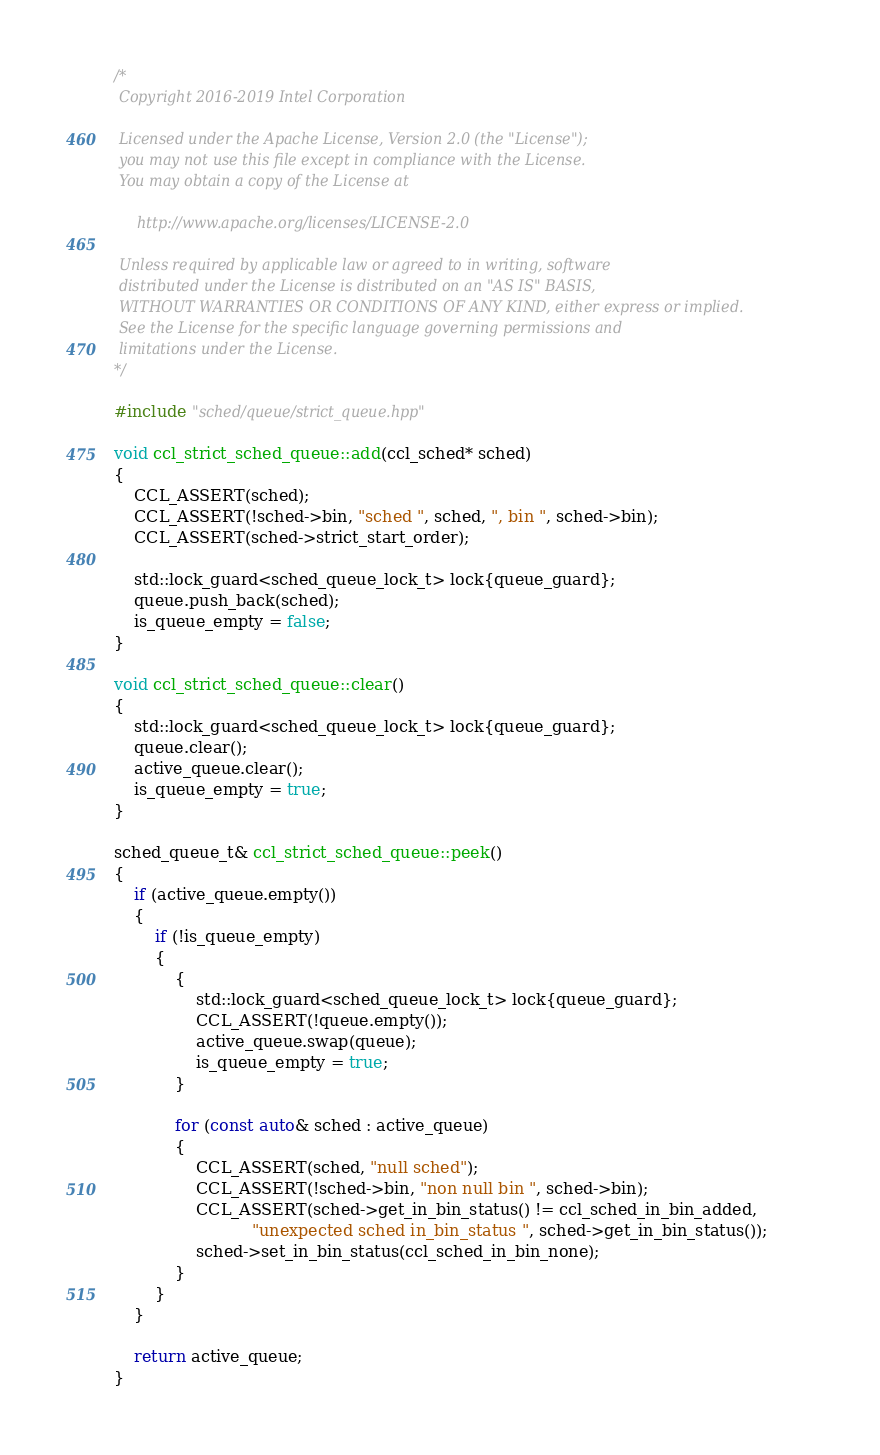<code> <loc_0><loc_0><loc_500><loc_500><_C++_>/*
 Copyright 2016-2019 Intel Corporation
 
 Licensed under the Apache License, Version 2.0 (the "License");
 you may not use this file except in compliance with the License.
 You may obtain a copy of the License at
 
     http://www.apache.org/licenses/LICENSE-2.0
 
 Unless required by applicable law or agreed to in writing, software
 distributed under the License is distributed on an "AS IS" BASIS,
 WITHOUT WARRANTIES OR CONDITIONS OF ANY KIND, either express or implied.
 See the License for the specific language governing permissions and
 limitations under the License.
*/

#include "sched/queue/strict_queue.hpp"

void ccl_strict_sched_queue::add(ccl_sched* sched)
{
    CCL_ASSERT(sched);
    CCL_ASSERT(!sched->bin, "sched ", sched, ", bin ", sched->bin);
    CCL_ASSERT(sched->strict_start_order);

    std::lock_guard<sched_queue_lock_t> lock{queue_guard};
    queue.push_back(sched);
    is_queue_empty = false;
}

void ccl_strict_sched_queue::clear()
{
    std::lock_guard<sched_queue_lock_t> lock{queue_guard};
    queue.clear();
    active_queue.clear();
    is_queue_empty = true;
}

sched_queue_t& ccl_strict_sched_queue::peek()
{
    if (active_queue.empty())
    {
        if (!is_queue_empty)
        {
            {
                std::lock_guard<sched_queue_lock_t> lock{queue_guard};
                CCL_ASSERT(!queue.empty());
                active_queue.swap(queue);
                is_queue_empty = true;
            }

            for (const auto& sched : active_queue)
            {
                CCL_ASSERT(sched, "null sched");
                CCL_ASSERT(!sched->bin, "non null bin ", sched->bin);
                CCL_ASSERT(sched->get_in_bin_status() != ccl_sched_in_bin_added,
                           "unexpected sched in_bin_status ", sched->get_in_bin_status());
                sched->set_in_bin_status(ccl_sched_in_bin_none);
            }
        }
    }

    return active_queue;
}
</code> 